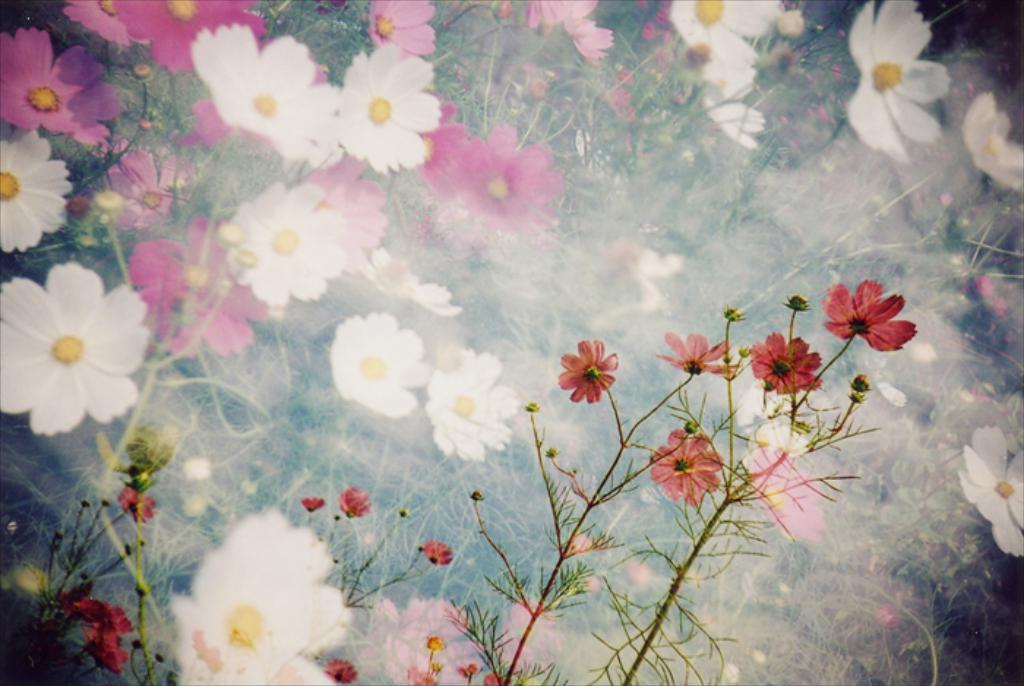What type of living organisms can be seen in the image? Plants can be seen in the image. What specific features can be observed on the plants? The plants have flowers and buds. What type of rat can be seen interacting with the plants in the image? There is no rat present in the image; it features plants with flowers and buds. Can you tell me how many bags are visible in the image? There are no bags present in the image. 